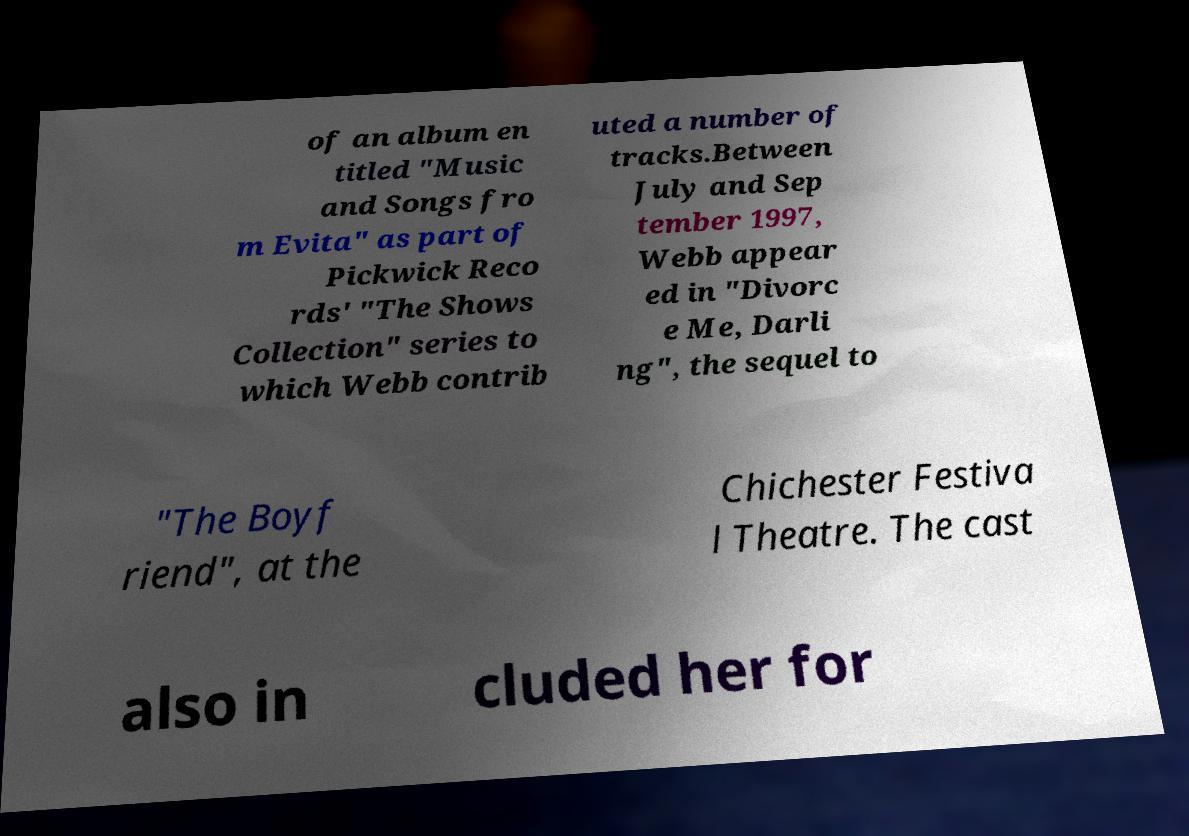What messages or text are displayed in this image? I need them in a readable, typed format. of an album en titled "Music and Songs fro m Evita" as part of Pickwick Reco rds' "The Shows Collection" series to which Webb contrib uted a number of tracks.Between July and Sep tember 1997, Webb appear ed in "Divorc e Me, Darli ng", the sequel to "The Boyf riend", at the Chichester Festiva l Theatre. The cast also in cluded her for 